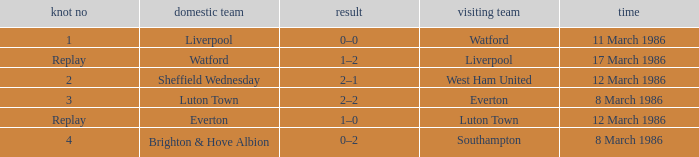Who was the home team in the match against Luton Town? Everton. 